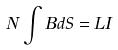Convert formula to latex. <formula><loc_0><loc_0><loc_500><loc_500>N \int B d S = L I</formula> 